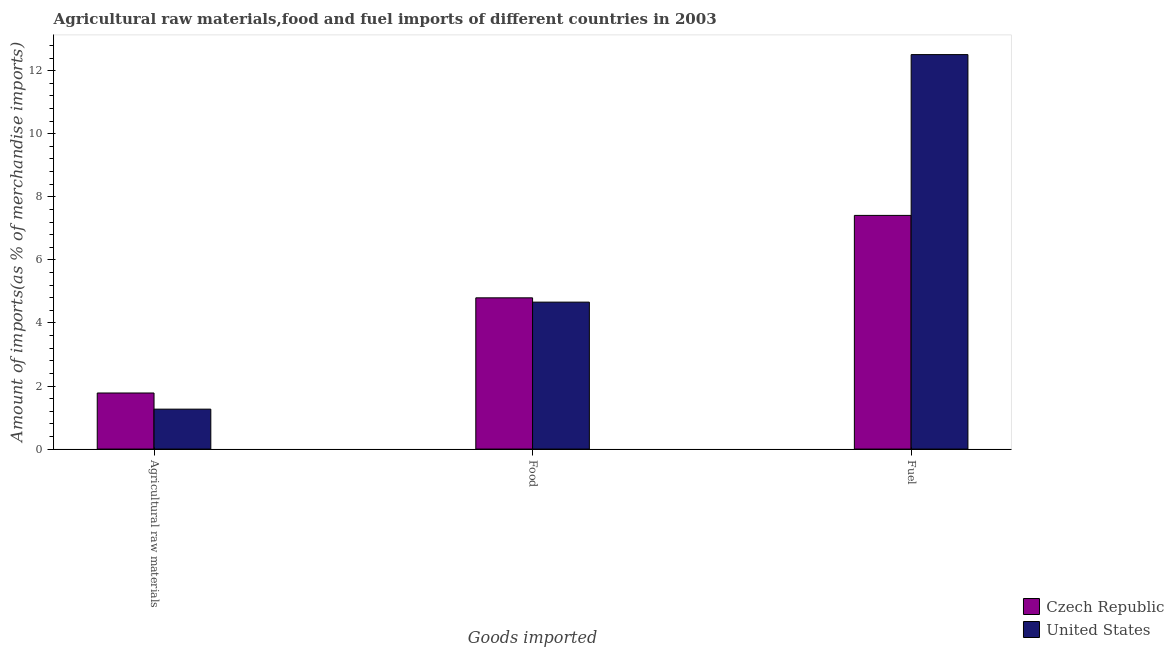How many different coloured bars are there?
Your answer should be compact. 2. How many groups of bars are there?
Offer a very short reply. 3. Are the number of bars per tick equal to the number of legend labels?
Your response must be concise. Yes. Are the number of bars on each tick of the X-axis equal?
Your response must be concise. Yes. How many bars are there on the 2nd tick from the left?
Give a very brief answer. 2. What is the label of the 1st group of bars from the left?
Ensure brevity in your answer.  Agricultural raw materials. What is the percentage of fuel imports in Czech Republic?
Provide a short and direct response. 7.41. Across all countries, what is the maximum percentage of fuel imports?
Offer a very short reply. 12.51. Across all countries, what is the minimum percentage of raw materials imports?
Your answer should be very brief. 1.27. In which country was the percentage of food imports maximum?
Ensure brevity in your answer.  Czech Republic. What is the total percentage of fuel imports in the graph?
Provide a succinct answer. 19.92. What is the difference between the percentage of fuel imports in Czech Republic and that in United States?
Offer a terse response. -5.1. What is the difference between the percentage of raw materials imports in United States and the percentage of food imports in Czech Republic?
Your response must be concise. -3.53. What is the average percentage of fuel imports per country?
Your answer should be compact. 9.96. What is the difference between the percentage of food imports and percentage of fuel imports in United States?
Your response must be concise. -7.85. In how many countries, is the percentage of raw materials imports greater than 12 %?
Your answer should be compact. 0. What is the ratio of the percentage of raw materials imports in Czech Republic to that in United States?
Keep it short and to the point. 1.4. What is the difference between the highest and the second highest percentage of raw materials imports?
Offer a terse response. 0.51. What is the difference between the highest and the lowest percentage of raw materials imports?
Provide a succinct answer. 0.51. In how many countries, is the percentage of raw materials imports greater than the average percentage of raw materials imports taken over all countries?
Provide a short and direct response. 1. Is the sum of the percentage of fuel imports in Czech Republic and United States greater than the maximum percentage of raw materials imports across all countries?
Offer a terse response. Yes. What does the 2nd bar from the right in Agricultural raw materials represents?
Provide a short and direct response. Czech Republic. How many bars are there?
Your answer should be very brief. 6. What is the difference between two consecutive major ticks on the Y-axis?
Offer a very short reply. 2. Does the graph contain grids?
Offer a terse response. No. How many legend labels are there?
Your answer should be compact. 2. What is the title of the graph?
Provide a short and direct response. Agricultural raw materials,food and fuel imports of different countries in 2003. Does "Heavily indebted poor countries" appear as one of the legend labels in the graph?
Provide a succinct answer. No. What is the label or title of the X-axis?
Give a very brief answer. Goods imported. What is the label or title of the Y-axis?
Offer a very short reply. Amount of imports(as % of merchandise imports). What is the Amount of imports(as % of merchandise imports) in Czech Republic in Agricultural raw materials?
Ensure brevity in your answer.  1.78. What is the Amount of imports(as % of merchandise imports) of United States in Agricultural raw materials?
Give a very brief answer. 1.27. What is the Amount of imports(as % of merchandise imports) in Czech Republic in Food?
Your response must be concise. 4.8. What is the Amount of imports(as % of merchandise imports) in United States in Food?
Provide a short and direct response. 4.66. What is the Amount of imports(as % of merchandise imports) of Czech Republic in Fuel?
Provide a short and direct response. 7.41. What is the Amount of imports(as % of merchandise imports) in United States in Fuel?
Your answer should be very brief. 12.51. Across all Goods imported, what is the maximum Amount of imports(as % of merchandise imports) of Czech Republic?
Your answer should be very brief. 7.41. Across all Goods imported, what is the maximum Amount of imports(as % of merchandise imports) in United States?
Ensure brevity in your answer.  12.51. Across all Goods imported, what is the minimum Amount of imports(as % of merchandise imports) of Czech Republic?
Make the answer very short. 1.78. Across all Goods imported, what is the minimum Amount of imports(as % of merchandise imports) in United States?
Give a very brief answer. 1.27. What is the total Amount of imports(as % of merchandise imports) of Czech Republic in the graph?
Ensure brevity in your answer.  13.98. What is the total Amount of imports(as % of merchandise imports) of United States in the graph?
Offer a very short reply. 18.44. What is the difference between the Amount of imports(as % of merchandise imports) of Czech Republic in Agricultural raw materials and that in Food?
Offer a very short reply. -3.02. What is the difference between the Amount of imports(as % of merchandise imports) of United States in Agricultural raw materials and that in Food?
Your answer should be very brief. -3.39. What is the difference between the Amount of imports(as % of merchandise imports) in Czech Republic in Agricultural raw materials and that in Fuel?
Provide a succinct answer. -5.63. What is the difference between the Amount of imports(as % of merchandise imports) in United States in Agricultural raw materials and that in Fuel?
Give a very brief answer. -11.24. What is the difference between the Amount of imports(as % of merchandise imports) in Czech Republic in Food and that in Fuel?
Offer a very short reply. -2.61. What is the difference between the Amount of imports(as % of merchandise imports) in United States in Food and that in Fuel?
Offer a very short reply. -7.85. What is the difference between the Amount of imports(as % of merchandise imports) of Czech Republic in Agricultural raw materials and the Amount of imports(as % of merchandise imports) of United States in Food?
Your response must be concise. -2.88. What is the difference between the Amount of imports(as % of merchandise imports) in Czech Republic in Agricultural raw materials and the Amount of imports(as % of merchandise imports) in United States in Fuel?
Offer a terse response. -10.73. What is the difference between the Amount of imports(as % of merchandise imports) in Czech Republic in Food and the Amount of imports(as % of merchandise imports) in United States in Fuel?
Your answer should be very brief. -7.71. What is the average Amount of imports(as % of merchandise imports) of Czech Republic per Goods imported?
Your answer should be compact. 4.66. What is the average Amount of imports(as % of merchandise imports) in United States per Goods imported?
Provide a short and direct response. 6.14. What is the difference between the Amount of imports(as % of merchandise imports) of Czech Republic and Amount of imports(as % of merchandise imports) of United States in Agricultural raw materials?
Ensure brevity in your answer.  0.51. What is the difference between the Amount of imports(as % of merchandise imports) in Czech Republic and Amount of imports(as % of merchandise imports) in United States in Food?
Your answer should be very brief. 0.14. What is the difference between the Amount of imports(as % of merchandise imports) of Czech Republic and Amount of imports(as % of merchandise imports) of United States in Fuel?
Your answer should be compact. -5.1. What is the ratio of the Amount of imports(as % of merchandise imports) of Czech Republic in Agricultural raw materials to that in Food?
Give a very brief answer. 0.37. What is the ratio of the Amount of imports(as % of merchandise imports) of United States in Agricultural raw materials to that in Food?
Ensure brevity in your answer.  0.27. What is the ratio of the Amount of imports(as % of merchandise imports) of Czech Republic in Agricultural raw materials to that in Fuel?
Ensure brevity in your answer.  0.24. What is the ratio of the Amount of imports(as % of merchandise imports) in United States in Agricultural raw materials to that in Fuel?
Provide a short and direct response. 0.1. What is the ratio of the Amount of imports(as % of merchandise imports) in Czech Republic in Food to that in Fuel?
Provide a succinct answer. 0.65. What is the ratio of the Amount of imports(as % of merchandise imports) of United States in Food to that in Fuel?
Provide a short and direct response. 0.37. What is the difference between the highest and the second highest Amount of imports(as % of merchandise imports) of Czech Republic?
Your answer should be compact. 2.61. What is the difference between the highest and the second highest Amount of imports(as % of merchandise imports) in United States?
Give a very brief answer. 7.85. What is the difference between the highest and the lowest Amount of imports(as % of merchandise imports) in Czech Republic?
Make the answer very short. 5.63. What is the difference between the highest and the lowest Amount of imports(as % of merchandise imports) in United States?
Your answer should be compact. 11.24. 